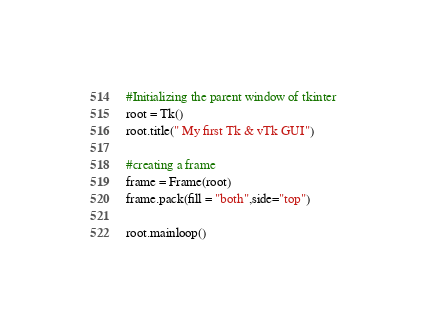Convert code to text. <code><loc_0><loc_0><loc_500><loc_500><_Python_>

#Initializing the parent window of tkinter
root = Tk()
root.title(" My first Tk & vTk GUI")

#creating a frame
frame = Frame(root)
frame.pack(fill = "both",side="top")

root.mainloop()

</code> 